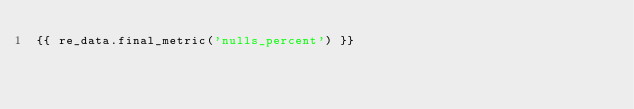Convert code to text. <code><loc_0><loc_0><loc_500><loc_500><_SQL_>{{ re_data.final_metric('nulls_percent') }}</code> 